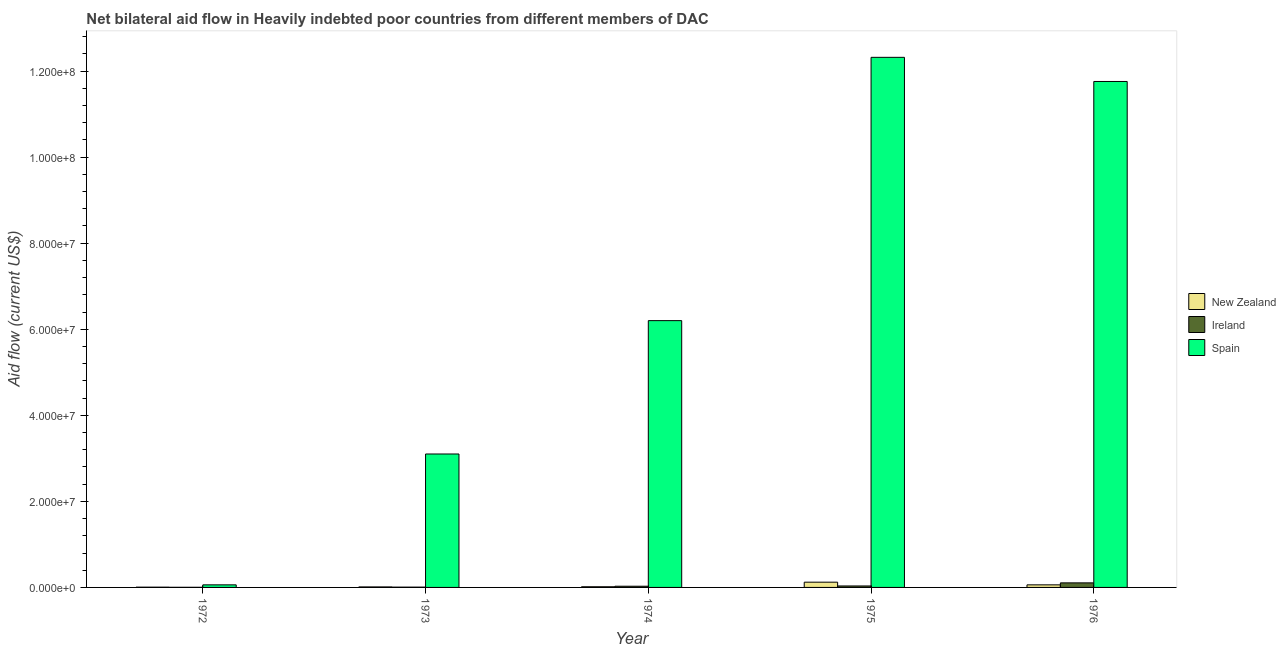How many different coloured bars are there?
Give a very brief answer. 3. How many groups of bars are there?
Keep it short and to the point. 5. How many bars are there on the 3rd tick from the left?
Make the answer very short. 3. How many bars are there on the 1st tick from the right?
Provide a succinct answer. 3. What is the label of the 5th group of bars from the left?
Keep it short and to the point. 1976. In how many cases, is the number of bars for a given year not equal to the number of legend labels?
Offer a terse response. 0. What is the amount of aid provided by spain in 1972?
Provide a short and direct response. 6.00e+05. Across all years, what is the maximum amount of aid provided by ireland?
Keep it short and to the point. 1.06e+06. Across all years, what is the minimum amount of aid provided by new zealand?
Your answer should be compact. 6.00e+04. In which year was the amount of aid provided by ireland maximum?
Provide a succinct answer. 1976. What is the total amount of aid provided by spain in the graph?
Give a very brief answer. 3.34e+08. What is the difference between the amount of aid provided by new zealand in 1975 and that in 1976?
Offer a terse response. 6.20e+05. What is the difference between the amount of aid provided by ireland in 1975 and the amount of aid provided by spain in 1972?
Your response must be concise. 3.10e+05. What is the average amount of aid provided by spain per year?
Keep it short and to the point. 6.69e+07. In the year 1972, what is the difference between the amount of aid provided by ireland and amount of aid provided by new zealand?
Offer a very short reply. 0. In how many years, is the amount of aid provided by spain greater than 112000000 US$?
Give a very brief answer. 2. What is the ratio of the amount of aid provided by spain in 1972 to that in 1975?
Your response must be concise. 0. Is the amount of aid provided by ireland in 1972 less than that in 1973?
Your response must be concise. Yes. What is the difference between the highest and the second highest amount of aid provided by new zealand?
Your response must be concise. 6.20e+05. What is the difference between the highest and the lowest amount of aid provided by spain?
Give a very brief answer. 1.23e+08. What does the 3rd bar from the left in 1973 represents?
Make the answer very short. Spain. What does the 2nd bar from the right in 1975 represents?
Ensure brevity in your answer.  Ireland. Are the values on the major ticks of Y-axis written in scientific E-notation?
Keep it short and to the point. Yes. Does the graph contain any zero values?
Provide a succinct answer. No. Does the graph contain grids?
Your answer should be compact. No. What is the title of the graph?
Provide a short and direct response. Net bilateral aid flow in Heavily indebted poor countries from different members of DAC. What is the Aid flow (current US$) in New Zealand in 1972?
Your answer should be compact. 6.00e+04. What is the Aid flow (current US$) in Ireland in 1972?
Keep it short and to the point. 3.00e+04. What is the Aid flow (current US$) in Spain in 1972?
Provide a succinct answer. 6.00e+05. What is the Aid flow (current US$) of Spain in 1973?
Ensure brevity in your answer.  3.10e+07. What is the Aid flow (current US$) in Spain in 1974?
Keep it short and to the point. 6.20e+07. What is the Aid flow (current US$) of New Zealand in 1975?
Make the answer very short. 1.22e+06. What is the Aid flow (current US$) in Ireland in 1975?
Your response must be concise. 3.40e+05. What is the Aid flow (current US$) in Spain in 1975?
Provide a short and direct response. 1.23e+08. What is the Aid flow (current US$) in New Zealand in 1976?
Ensure brevity in your answer.  6.00e+05. What is the Aid flow (current US$) in Ireland in 1976?
Provide a short and direct response. 1.06e+06. What is the Aid flow (current US$) in Spain in 1976?
Keep it short and to the point. 1.18e+08. Across all years, what is the maximum Aid flow (current US$) in New Zealand?
Provide a short and direct response. 1.22e+06. Across all years, what is the maximum Aid flow (current US$) in Ireland?
Give a very brief answer. 1.06e+06. Across all years, what is the maximum Aid flow (current US$) of Spain?
Make the answer very short. 1.23e+08. Across all years, what is the minimum Aid flow (current US$) in Ireland?
Your answer should be compact. 3.00e+04. Across all years, what is the minimum Aid flow (current US$) in Spain?
Offer a terse response. 6.00e+05. What is the total Aid flow (current US$) of New Zealand in the graph?
Provide a succinct answer. 2.16e+06. What is the total Aid flow (current US$) of Ireland in the graph?
Your answer should be compact. 1.78e+06. What is the total Aid flow (current US$) in Spain in the graph?
Provide a succinct answer. 3.34e+08. What is the difference between the Aid flow (current US$) in Ireland in 1972 and that in 1973?
Your answer should be very brief. -4.00e+04. What is the difference between the Aid flow (current US$) in Spain in 1972 and that in 1973?
Provide a short and direct response. -3.04e+07. What is the difference between the Aid flow (current US$) of Spain in 1972 and that in 1974?
Your answer should be compact. -6.14e+07. What is the difference between the Aid flow (current US$) of New Zealand in 1972 and that in 1975?
Give a very brief answer. -1.16e+06. What is the difference between the Aid flow (current US$) of Ireland in 1972 and that in 1975?
Your answer should be very brief. -3.10e+05. What is the difference between the Aid flow (current US$) of Spain in 1972 and that in 1975?
Your response must be concise. -1.23e+08. What is the difference between the Aid flow (current US$) of New Zealand in 1972 and that in 1976?
Ensure brevity in your answer.  -5.40e+05. What is the difference between the Aid flow (current US$) in Ireland in 1972 and that in 1976?
Make the answer very short. -1.03e+06. What is the difference between the Aid flow (current US$) of Spain in 1972 and that in 1976?
Your response must be concise. -1.17e+08. What is the difference between the Aid flow (current US$) in Spain in 1973 and that in 1974?
Give a very brief answer. -3.10e+07. What is the difference between the Aid flow (current US$) of New Zealand in 1973 and that in 1975?
Your answer should be very brief. -1.10e+06. What is the difference between the Aid flow (current US$) of Spain in 1973 and that in 1975?
Offer a very short reply. -9.22e+07. What is the difference between the Aid flow (current US$) of New Zealand in 1973 and that in 1976?
Your answer should be compact. -4.80e+05. What is the difference between the Aid flow (current US$) in Ireland in 1973 and that in 1976?
Provide a succinct answer. -9.90e+05. What is the difference between the Aid flow (current US$) of Spain in 1973 and that in 1976?
Provide a short and direct response. -8.66e+07. What is the difference between the Aid flow (current US$) of New Zealand in 1974 and that in 1975?
Provide a short and direct response. -1.06e+06. What is the difference between the Aid flow (current US$) of Ireland in 1974 and that in 1975?
Offer a terse response. -6.00e+04. What is the difference between the Aid flow (current US$) in Spain in 1974 and that in 1975?
Keep it short and to the point. -6.12e+07. What is the difference between the Aid flow (current US$) of New Zealand in 1974 and that in 1976?
Give a very brief answer. -4.40e+05. What is the difference between the Aid flow (current US$) of Ireland in 1974 and that in 1976?
Make the answer very short. -7.80e+05. What is the difference between the Aid flow (current US$) of Spain in 1974 and that in 1976?
Your answer should be very brief. -5.56e+07. What is the difference between the Aid flow (current US$) in New Zealand in 1975 and that in 1976?
Give a very brief answer. 6.20e+05. What is the difference between the Aid flow (current US$) of Ireland in 1975 and that in 1976?
Your answer should be very brief. -7.20e+05. What is the difference between the Aid flow (current US$) of Spain in 1975 and that in 1976?
Ensure brevity in your answer.  5.61e+06. What is the difference between the Aid flow (current US$) of New Zealand in 1972 and the Aid flow (current US$) of Ireland in 1973?
Offer a very short reply. -10000. What is the difference between the Aid flow (current US$) of New Zealand in 1972 and the Aid flow (current US$) of Spain in 1973?
Make the answer very short. -3.10e+07. What is the difference between the Aid flow (current US$) of Ireland in 1972 and the Aid flow (current US$) of Spain in 1973?
Offer a very short reply. -3.10e+07. What is the difference between the Aid flow (current US$) of New Zealand in 1972 and the Aid flow (current US$) of Ireland in 1974?
Ensure brevity in your answer.  -2.20e+05. What is the difference between the Aid flow (current US$) in New Zealand in 1972 and the Aid flow (current US$) in Spain in 1974?
Your answer should be compact. -6.19e+07. What is the difference between the Aid flow (current US$) of Ireland in 1972 and the Aid flow (current US$) of Spain in 1974?
Give a very brief answer. -6.20e+07. What is the difference between the Aid flow (current US$) in New Zealand in 1972 and the Aid flow (current US$) in Ireland in 1975?
Provide a succinct answer. -2.80e+05. What is the difference between the Aid flow (current US$) of New Zealand in 1972 and the Aid flow (current US$) of Spain in 1975?
Offer a terse response. -1.23e+08. What is the difference between the Aid flow (current US$) in Ireland in 1972 and the Aid flow (current US$) in Spain in 1975?
Keep it short and to the point. -1.23e+08. What is the difference between the Aid flow (current US$) of New Zealand in 1972 and the Aid flow (current US$) of Ireland in 1976?
Your answer should be very brief. -1.00e+06. What is the difference between the Aid flow (current US$) of New Zealand in 1972 and the Aid flow (current US$) of Spain in 1976?
Ensure brevity in your answer.  -1.18e+08. What is the difference between the Aid flow (current US$) of Ireland in 1972 and the Aid flow (current US$) of Spain in 1976?
Offer a terse response. -1.18e+08. What is the difference between the Aid flow (current US$) in New Zealand in 1973 and the Aid flow (current US$) in Ireland in 1974?
Provide a succinct answer. -1.60e+05. What is the difference between the Aid flow (current US$) in New Zealand in 1973 and the Aid flow (current US$) in Spain in 1974?
Keep it short and to the point. -6.19e+07. What is the difference between the Aid flow (current US$) of Ireland in 1973 and the Aid flow (current US$) of Spain in 1974?
Ensure brevity in your answer.  -6.19e+07. What is the difference between the Aid flow (current US$) of New Zealand in 1973 and the Aid flow (current US$) of Ireland in 1975?
Offer a terse response. -2.20e+05. What is the difference between the Aid flow (current US$) in New Zealand in 1973 and the Aid flow (current US$) in Spain in 1975?
Make the answer very short. -1.23e+08. What is the difference between the Aid flow (current US$) of Ireland in 1973 and the Aid flow (current US$) of Spain in 1975?
Your answer should be very brief. -1.23e+08. What is the difference between the Aid flow (current US$) of New Zealand in 1973 and the Aid flow (current US$) of Ireland in 1976?
Your answer should be very brief. -9.40e+05. What is the difference between the Aid flow (current US$) in New Zealand in 1973 and the Aid flow (current US$) in Spain in 1976?
Offer a very short reply. -1.17e+08. What is the difference between the Aid flow (current US$) of Ireland in 1973 and the Aid flow (current US$) of Spain in 1976?
Offer a very short reply. -1.18e+08. What is the difference between the Aid flow (current US$) in New Zealand in 1974 and the Aid flow (current US$) in Ireland in 1975?
Your response must be concise. -1.80e+05. What is the difference between the Aid flow (current US$) of New Zealand in 1974 and the Aid flow (current US$) of Spain in 1975?
Your response must be concise. -1.23e+08. What is the difference between the Aid flow (current US$) in Ireland in 1974 and the Aid flow (current US$) in Spain in 1975?
Give a very brief answer. -1.23e+08. What is the difference between the Aid flow (current US$) in New Zealand in 1974 and the Aid flow (current US$) in Ireland in 1976?
Your answer should be compact. -9.00e+05. What is the difference between the Aid flow (current US$) in New Zealand in 1974 and the Aid flow (current US$) in Spain in 1976?
Your response must be concise. -1.17e+08. What is the difference between the Aid flow (current US$) of Ireland in 1974 and the Aid flow (current US$) of Spain in 1976?
Make the answer very short. -1.17e+08. What is the difference between the Aid flow (current US$) in New Zealand in 1975 and the Aid flow (current US$) in Spain in 1976?
Give a very brief answer. -1.16e+08. What is the difference between the Aid flow (current US$) in Ireland in 1975 and the Aid flow (current US$) in Spain in 1976?
Offer a terse response. -1.17e+08. What is the average Aid flow (current US$) in New Zealand per year?
Make the answer very short. 4.32e+05. What is the average Aid flow (current US$) of Ireland per year?
Your answer should be very brief. 3.56e+05. What is the average Aid flow (current US$) in Spain per year?
Offer a terse response. 6.69e+07. In the year 1972, what is the difference between the Aid flow (current US$) in New Zealand and Aid flow (current US$) in Ireland?
Offer a very short reply. 3.00e+04. In the year 1972, what is the difference between the Aid flow (current US$) in New Zealand and Aid flow (current US$) in Spain?
Your answer should be compact. -5.40e+05. In the year 1972, what is the difference between the Aid flow (current US$) of Ireland and Aid flow (current US$) of Spain?
Provide a succinct answer. -5.70e+05. In the year 1973, what is the difference between the Aid flow (current US$) of New Zealand and Aid flow (current US$) of Ireland?
Offer a very short reply. 5.00e+04. In the year 1973, what is the difference between the Aid flow (current US$) in New Zealand and Aid flow (current US$) in Spain?
Offer a terse response. -3.09e+07. In the year 1973, what is the difference between the Aid flow (current US$) in Ireland and Aid flow (current US$) in Spain?
Offer a terse response. -3.09e+07. In the year 1974, what is the difference between the Aid flow (current US$) of New Zealand and Aid flow (current US$) of Spain?
Your response must be concise. -6.18e+07. In the year 1974, what is the difference between the Aid flow (current US$) of Ireland and Aid flow (current US$) of Spain?
Give a very brief answer. -6.17e+07. In the year 1975, what is the difference between the Aid flow (current US$) of New Zealand and Aid flow (current US$) of Ireland?
Offer a very short reply. 8.80e+05. In the year 1975, what is the difference between the Aid flow (current US$) of New Zealand and Aid flow (current US$) of Spain?
Provide a succinct answer. -1.22e+08. In the year 1975, what is the difference between the Aid flow (current US$) of Ireland and Aid flow (current US$) of Spain?
Make the answer very short. -1.23e+08. In the year 1976, what is the difference between the Aid flow (current US$) in New Zealand and Aid flow (current US$) in Ireland?
Make the answer very short. -4.60e+05. In the year 1976, what is the difference between the Aid flow (current US$) of New Zealand and Aid flow (current US$) of Spain?
Offer a terse response. -1.17e+08. In the year 1976, what is the difference between the Aid flow (current US$) of Ireland and Aid flow (current US$) of Spain?
Provide a succinct answer. -1.17e+08. What is the ratio of the Aid flow (current US$) of Ireland in 1972 to that in 1973?
Provide a short and direct response. 0.43. What is the ratio of the Aid flow (current US$) of Spain in 1972 to that in 1973?
Offer a terse response. 0.02. What is the ratio of the Aid flow (current US$) in New Zealand in 1972 to that in 1974?
Your answer should be very brief. 0.38. What is the ratio of the Aid flow (current US$) of Ireland in 1972 to that in 1974?
Keep it short and to the point. 0.11. What is the ratio of the Aid flow (current US$) of Spain in 1972 to that in 1974?
Ensure brevity in your answer.  0.01. What is the ratio of the Aid flow (current US$) in New Zealand in 1972 to that in 1975?
Give a very brief answer. 0.05. What is the ratio of the Aid flow (current US$) of Ireland in 1972 to that in 1975?
Provide a succinct answer. 0.09. What is the ratio of the Aid flow (current US$) in Spain in 1972 to that in 1975?
Give a very brief answer. 0. What is the ratio of the Aid flow (current US$) of New Zealand in 1972 to that in 1976?
Keep it short and to the point. 0.1. What is the ratio of the Aid flow (current US$) of Ireland in 1972 to that in 1976?
Your answer should be very brief. 0.03. What is the ratio of the Aid flow (current US$) of Spain in 1972 to that in 1976?
Offer a terse response. 0.01. What is the ratio of the Aid flow (current US$) in Ireland in 1973 to that in 1974?
Provide a succinct answer. 0.25. What is the ratio of the Aid flow (current US$) in Spain in 1973 to that in 1974?
Ensure brevity in your answer.  0.5. What is the ratio of the Aid flow (current US$) of New Zealand in 1973 to that in 1975?
Provide a succinct answer. 0.1. What is the ratio of the Aid flow (current US$) in Ireland in 1973 to that in 1975?
Provide a succinct answer. 0.21. What is the ratio of the Aid flow (current US$) of Spain in 1973 to that in 1975?
Offer a very short reply. 0.25. What is the ratio of the Aid flow (current US$) in Ireland in 1973 to that in 1976?
Provide a succinct answer. 0.07. What is the ratio of the Aid flow (current US$) in Spain in 1973 to that in 1976?
Keep it short and to the point. 0.26. What is the ratio of the Aid flow (current US$) in New Zealand in 1974 to that in 1975?
Provide a short and direct response. 0.13. What is the ratio of the Aid flow (current US$) in Ireland in 1974 to that in 1975?
Your answer should be compact. 0.82. What is the ratio of the Aid flow (current US$) of Spain in 1974 to that in 1975?
Your response must be concise. 0.5. What is the ratio of the Aid flow (current US$) of New Zealand in 1974 to that in 1976?
Your response must be concise. 0.27. What is the ratio of the Aid flow (current US$) of Ireland in 1974 to that in 1976?
Provide a short and direct response. 0.26. What is the ratio of the Aid flow (current US$) in Spain in 1974 to that in 1976?
Offer a very short reply. 0.53. What is the ratio of the Aid flow (current US$) of New Zealand in 1975 to that in 1976?
Give a very brief answer. 2.03. What is the ratio of the Aid flow (current US$) of Ireland in 1975 to that in 1976?
Your response must be concise. 0.32. What is the ratio of the Aid flow (current US$) of Spain in 1975 to that in 1976?
Provide a succinct answer. 1.05. What is the difference between the highest and the second highest Aid flow (current US$) in New Zealand?
Your response must be concise. 6.20e+05. What is the difference between the highest and the second highest Aid flow (current US$) of Ireland?
Provide a succinct answer. 7.20e+05. What is the difference between the highest and the second highest Aid flow (current US$) of Spain?
Provide a succinct answer. 5.61e+06. What is the difference between the highest and the lowest Aid flow (current US$) in New Zealand?
Give a very brief answer. 1.16e+06. What is the difference between the highest and the lowest Aid flow (current US$) of Ireland?
Make the answer very short. 1.03e+06. What is the difference between the highest and the lowest Aid flow (current US$) of Spain?
Keep it short and to the point. 1.23e+08. 